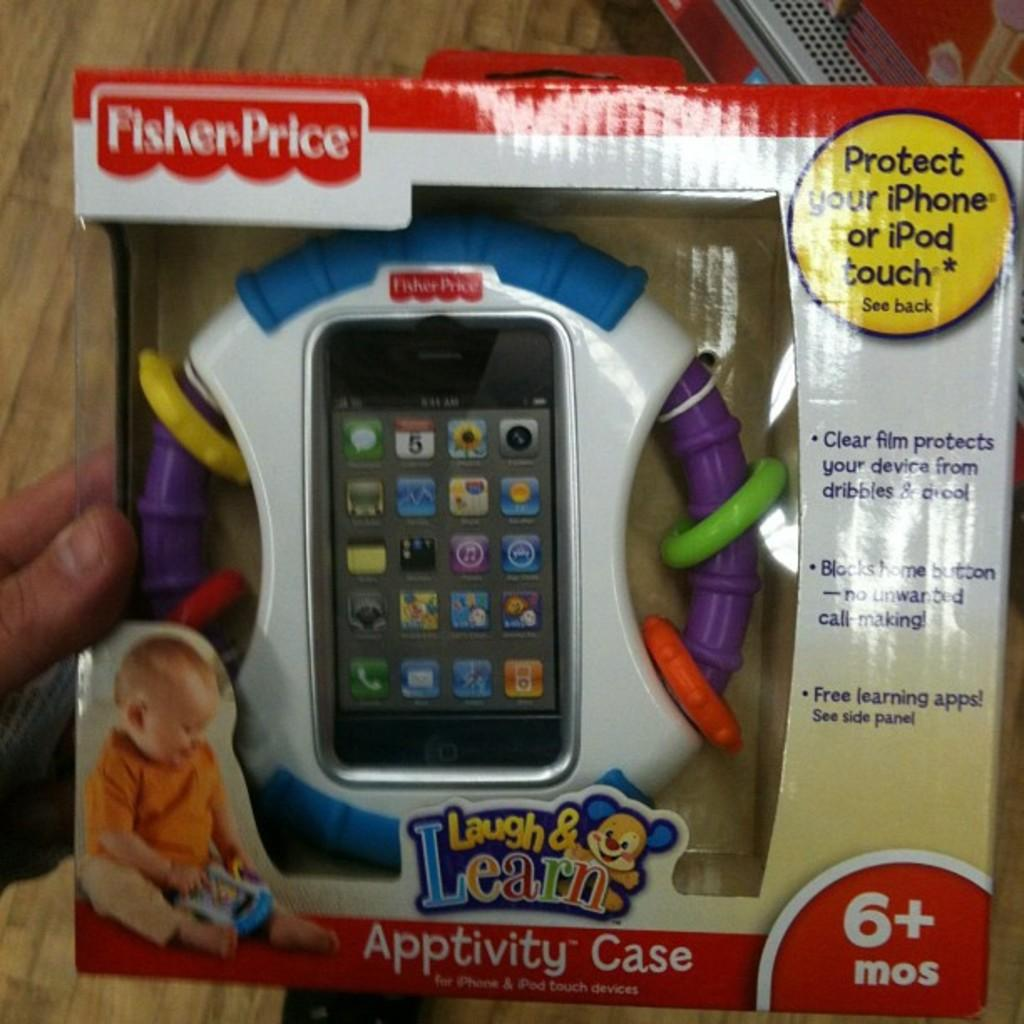<image>
Write a terse but informative summary of the picture. A phone case that is meant for ages six months and up. 